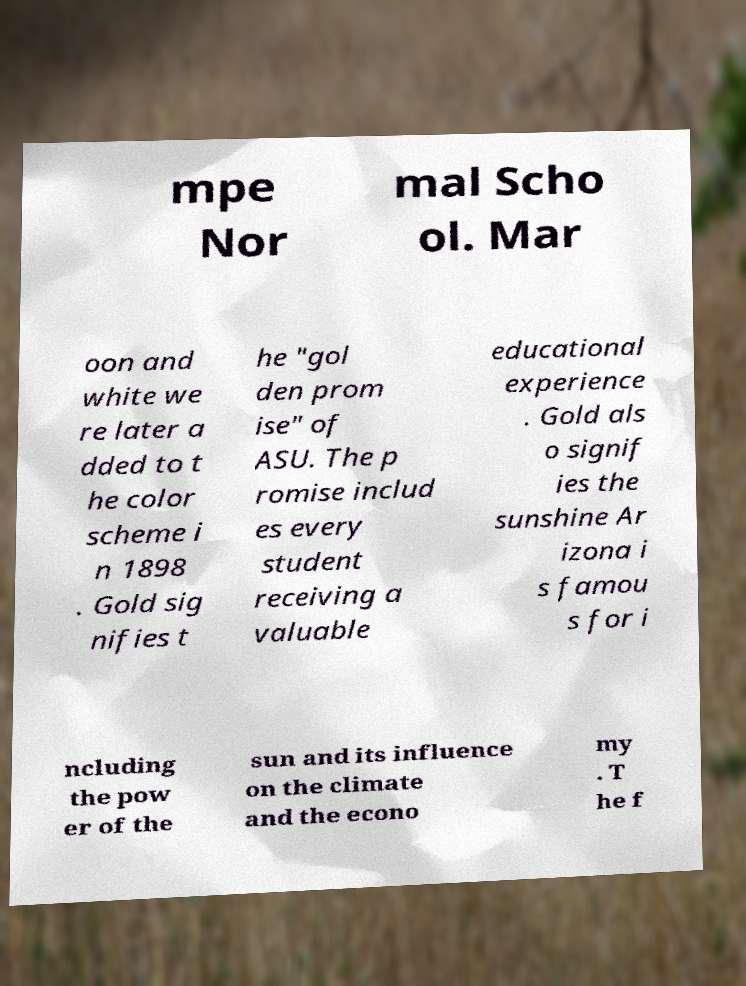Please identify and transcribe the text found in this image. mpe Nor mal Scho ol. Mar oon and white we re later a dded to t he color scheme i n 1898 . Gold sig nifies t he "gol den prom ise" of ASU. The p romise includ es every student receiving a valuable educational experience . Gold als o signif ies the sunshine Ar izona i s famou s for i ncluding the pow er of the sun and its influence on the climate and the econo my . T he f 